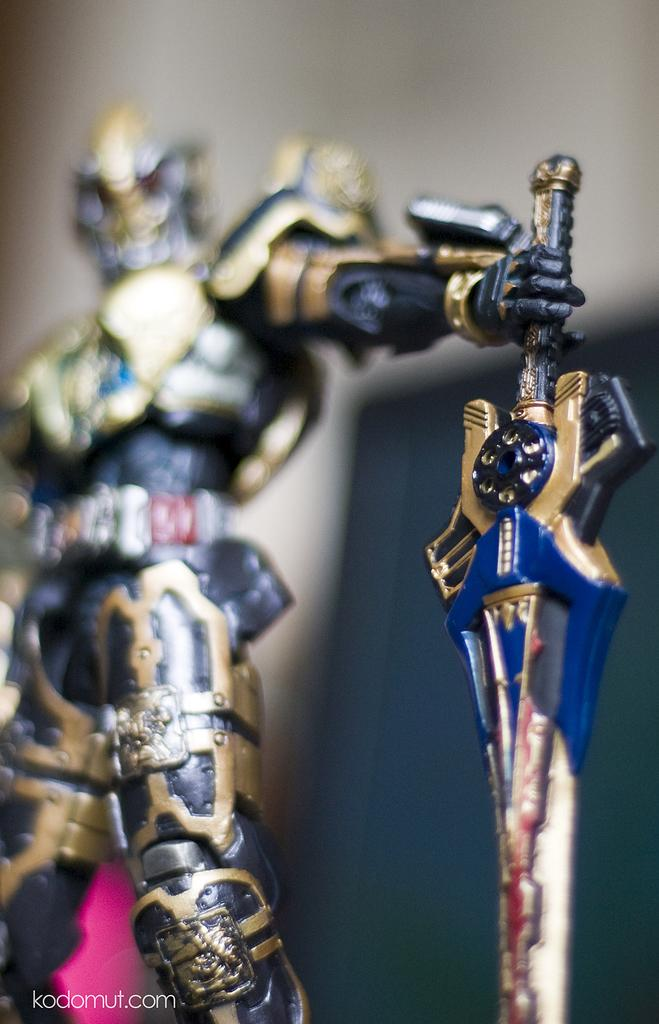What is the main subject of the image? There is a statue in the image. What is the statue depicting? The statue is of a person. What is the person wearing? The person is depicted wearing armour. What objects is the person holding? The person is holding a shield and a sword. How many frogs can be seen sitting on the sand near the statue in the image? There are no frogs or sand present in the image; it features a statue of a person wearing armour and holding a shield and a sword. 